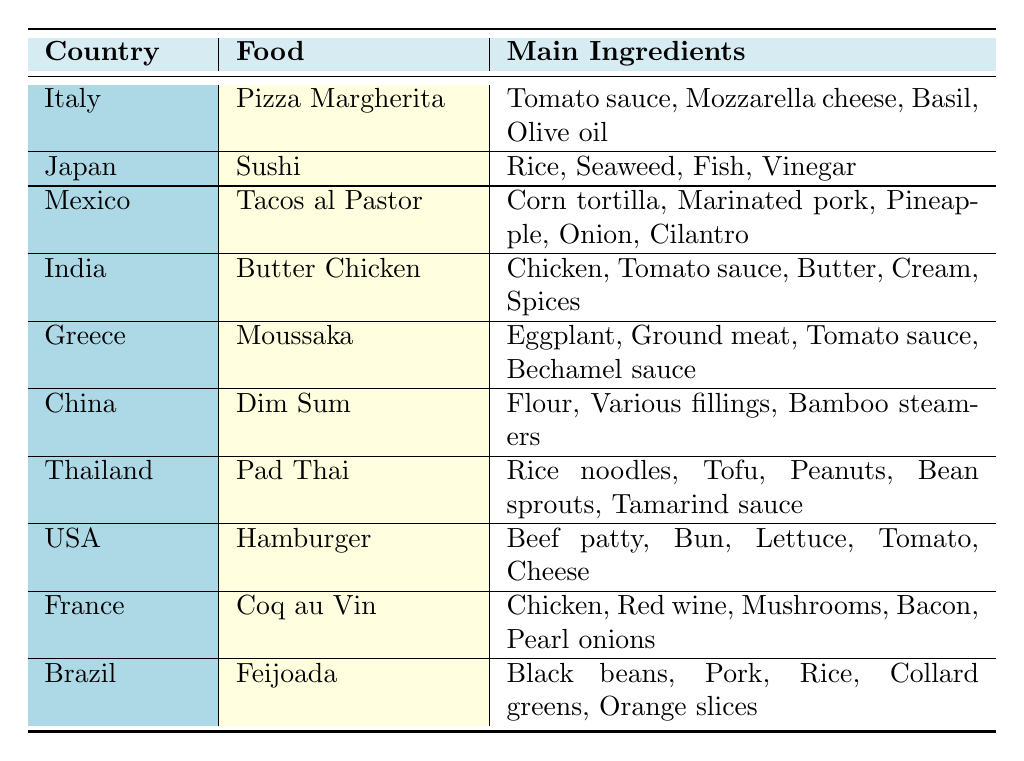What traditional food is made with rice and seaweed? Referring to the table, the food "Sushi" from Japan is specifically mentioned as being made with "Rice" and "Seaweed."
Answer: Sushi Which country’s traditional food contains black beans as a main ingredient? The table indicates that "Feijoada," a traditional food from Brazil, includes "Black beans" in its main ingredients list.
Answer: Brazil Is Tacos al Pastor made with beef? Checking the ingredients for "Tacos al Pastor," we see that it includes "Marinated pork," which means it does not contain beef.
Answer: No How many main ingredients does Butter Chicken have? By looking at the entry for "Butter Chicken" in India, we can count the ingredients listed: Chicken, Tomato sauce, Butter, Cream, and Spices; this gives us a total of 5 main ingredients.
Answer: 5 Which food contains both chicken and red wine among its ingredients? From the table, "Coq au Vin" from France includes both "Chicken" and "Red wine" listed as main ingredients.
Answer: Coq au Vin What is the only food listed that has mushrooms as an ingredient? The table reveals that "Coq au Vin" is the only dish that lists "Mushrooms" among its main ingredients.
Answer: Coq au Vin Are there more traditional foods with rice as an ingredient than those with beef? "Sushi," "Pad Thai," "Feijoada," and "Butter Chicken" all include rice as an ingredient while only "Hamburger" contains beef. Therefore, there are more foods with rice (4) than with beef (1).
Answer: Yes Which traditional food has the most diverse set of ingredients with at least 5 different components? Observing the table, "Tacos al Pastor" has 5 ingredients: Corn tortilla, Marinated pork, Pineapple, Onion, and Cilantro, while other entries are more limited. Most notably, "Pad Thai" also includes 5 ingredients but with a different composition. Thus, both have a diverse set of 5 ingredients.
Answer: Tacos al Pastor and Pad Thai What ingredient is common in both Italian and Thai traditional foods? "Olive oil" is a main ingredient in "Pizza Margherita" from Italy, while "Pad Thai" has "Peanuts" instead. After checking both dishes, neither share an ingredient, leading us to conclude that no common ingredient exists at this level.
Answer: None In which country can you find traditional food that utilizes bamboo steamers? The table points out that "Dim Sum" from China is the only food noted to utilize "Bamboo steamers" as part of its preparation method.
Answer: China 